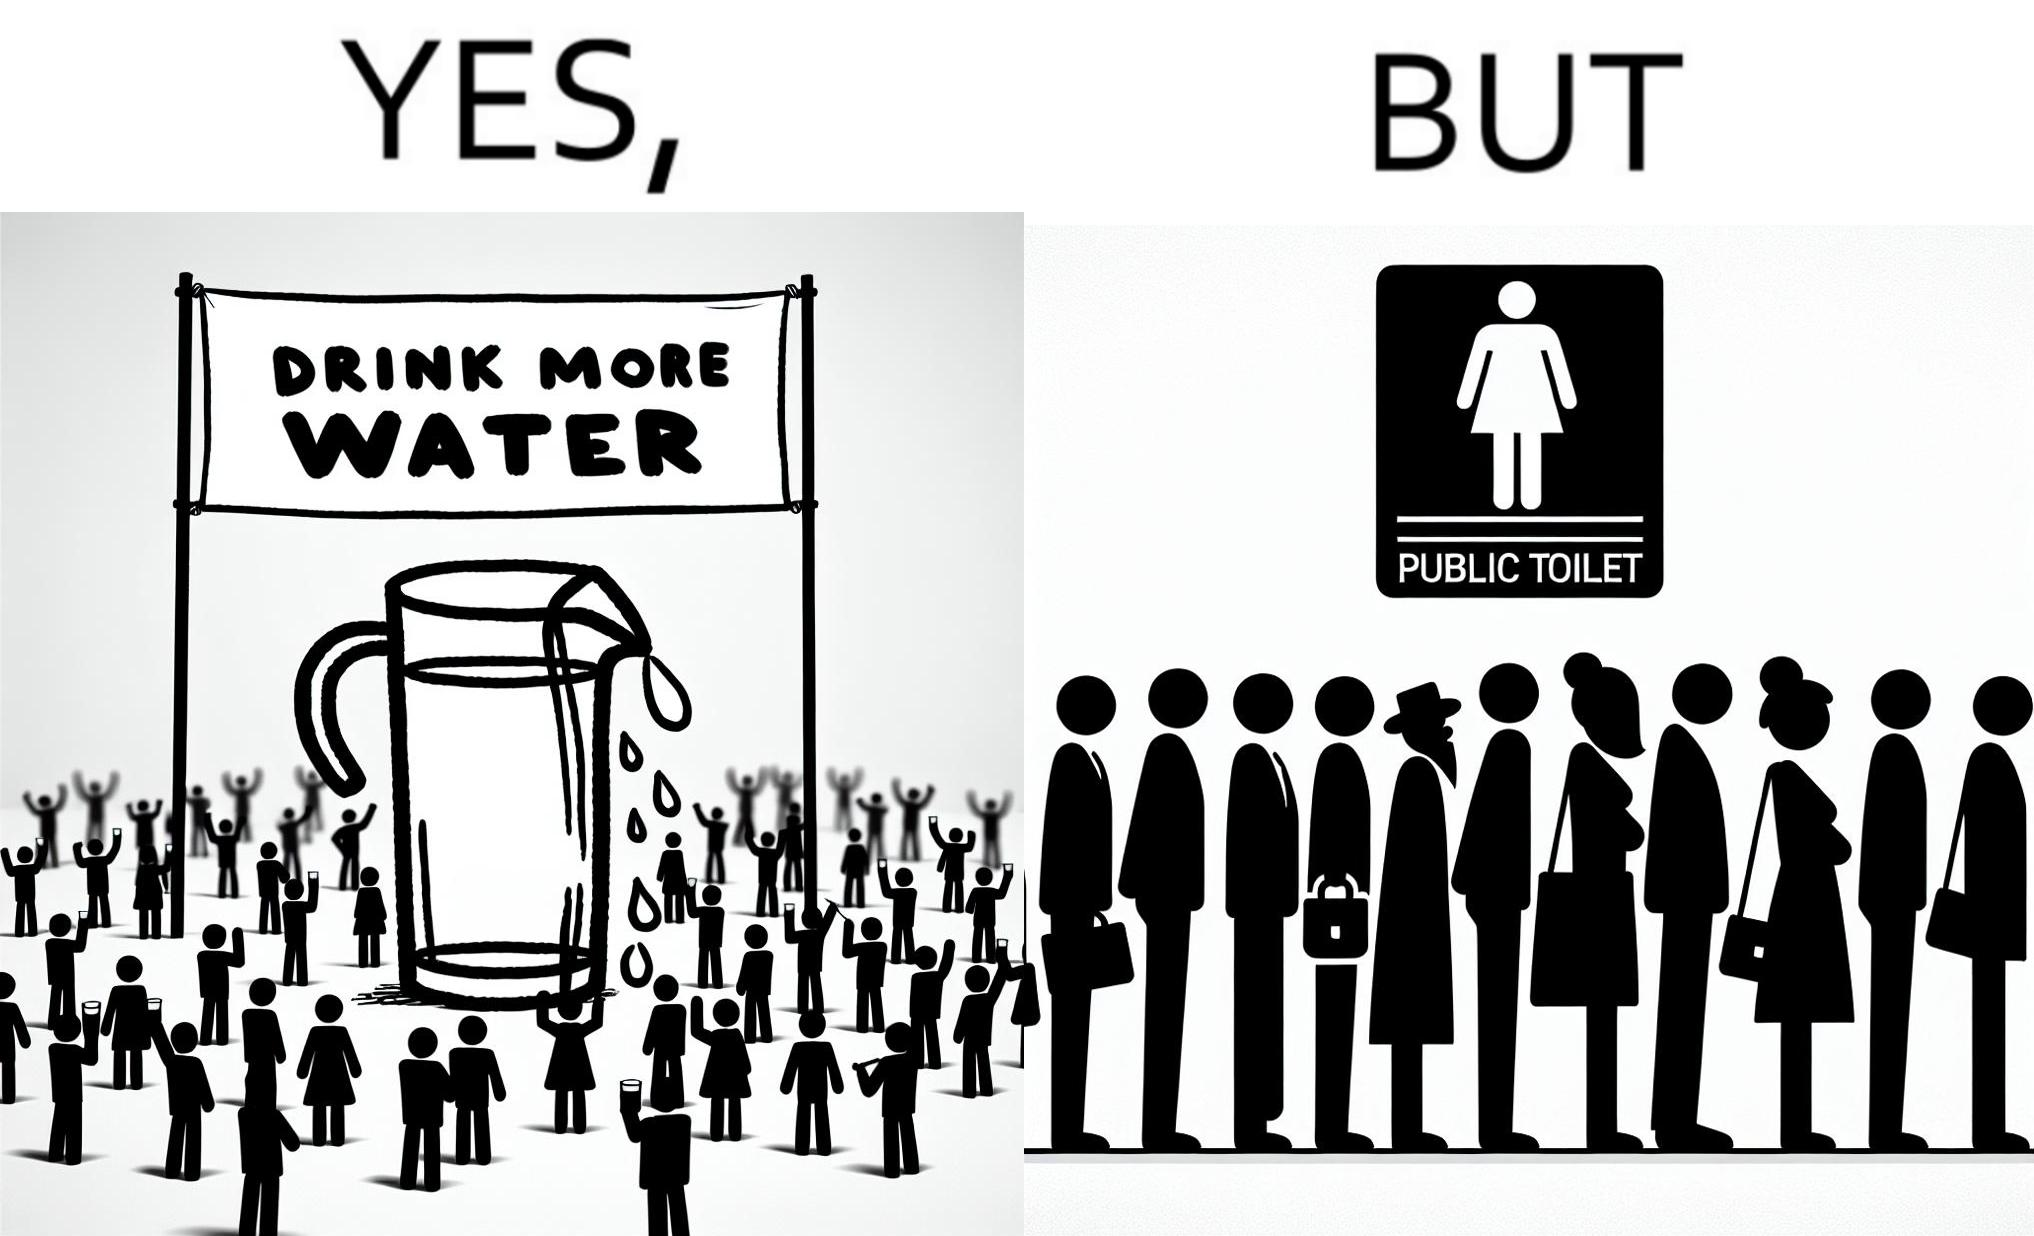Describe the satirical element in this image. The image is ironical, as the message "Drink more water" is meant to improve health, but in turn, it would lead to longer queues in front of public toilets, leading to people holding urine for longer periods, in turn leading to deterioration in health. 